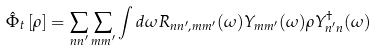<formula> <loc_0><loc_0><loc_500><loc_500>\hat { \Phi } _ { t } \left [ \rho \right ] = \sum _ { n n ^ { \prime } } \sum _ { m m ^ { \prime } } \int d \omega R _ { n n ^ { \prime } , m m ^ { \prime } } ( \omega ) Y _ { m m ^ { \prime } } ( \omega ) \rho Y _ { n ^ { \prime } n } ^ { \dag } ( \omega )</formula> 